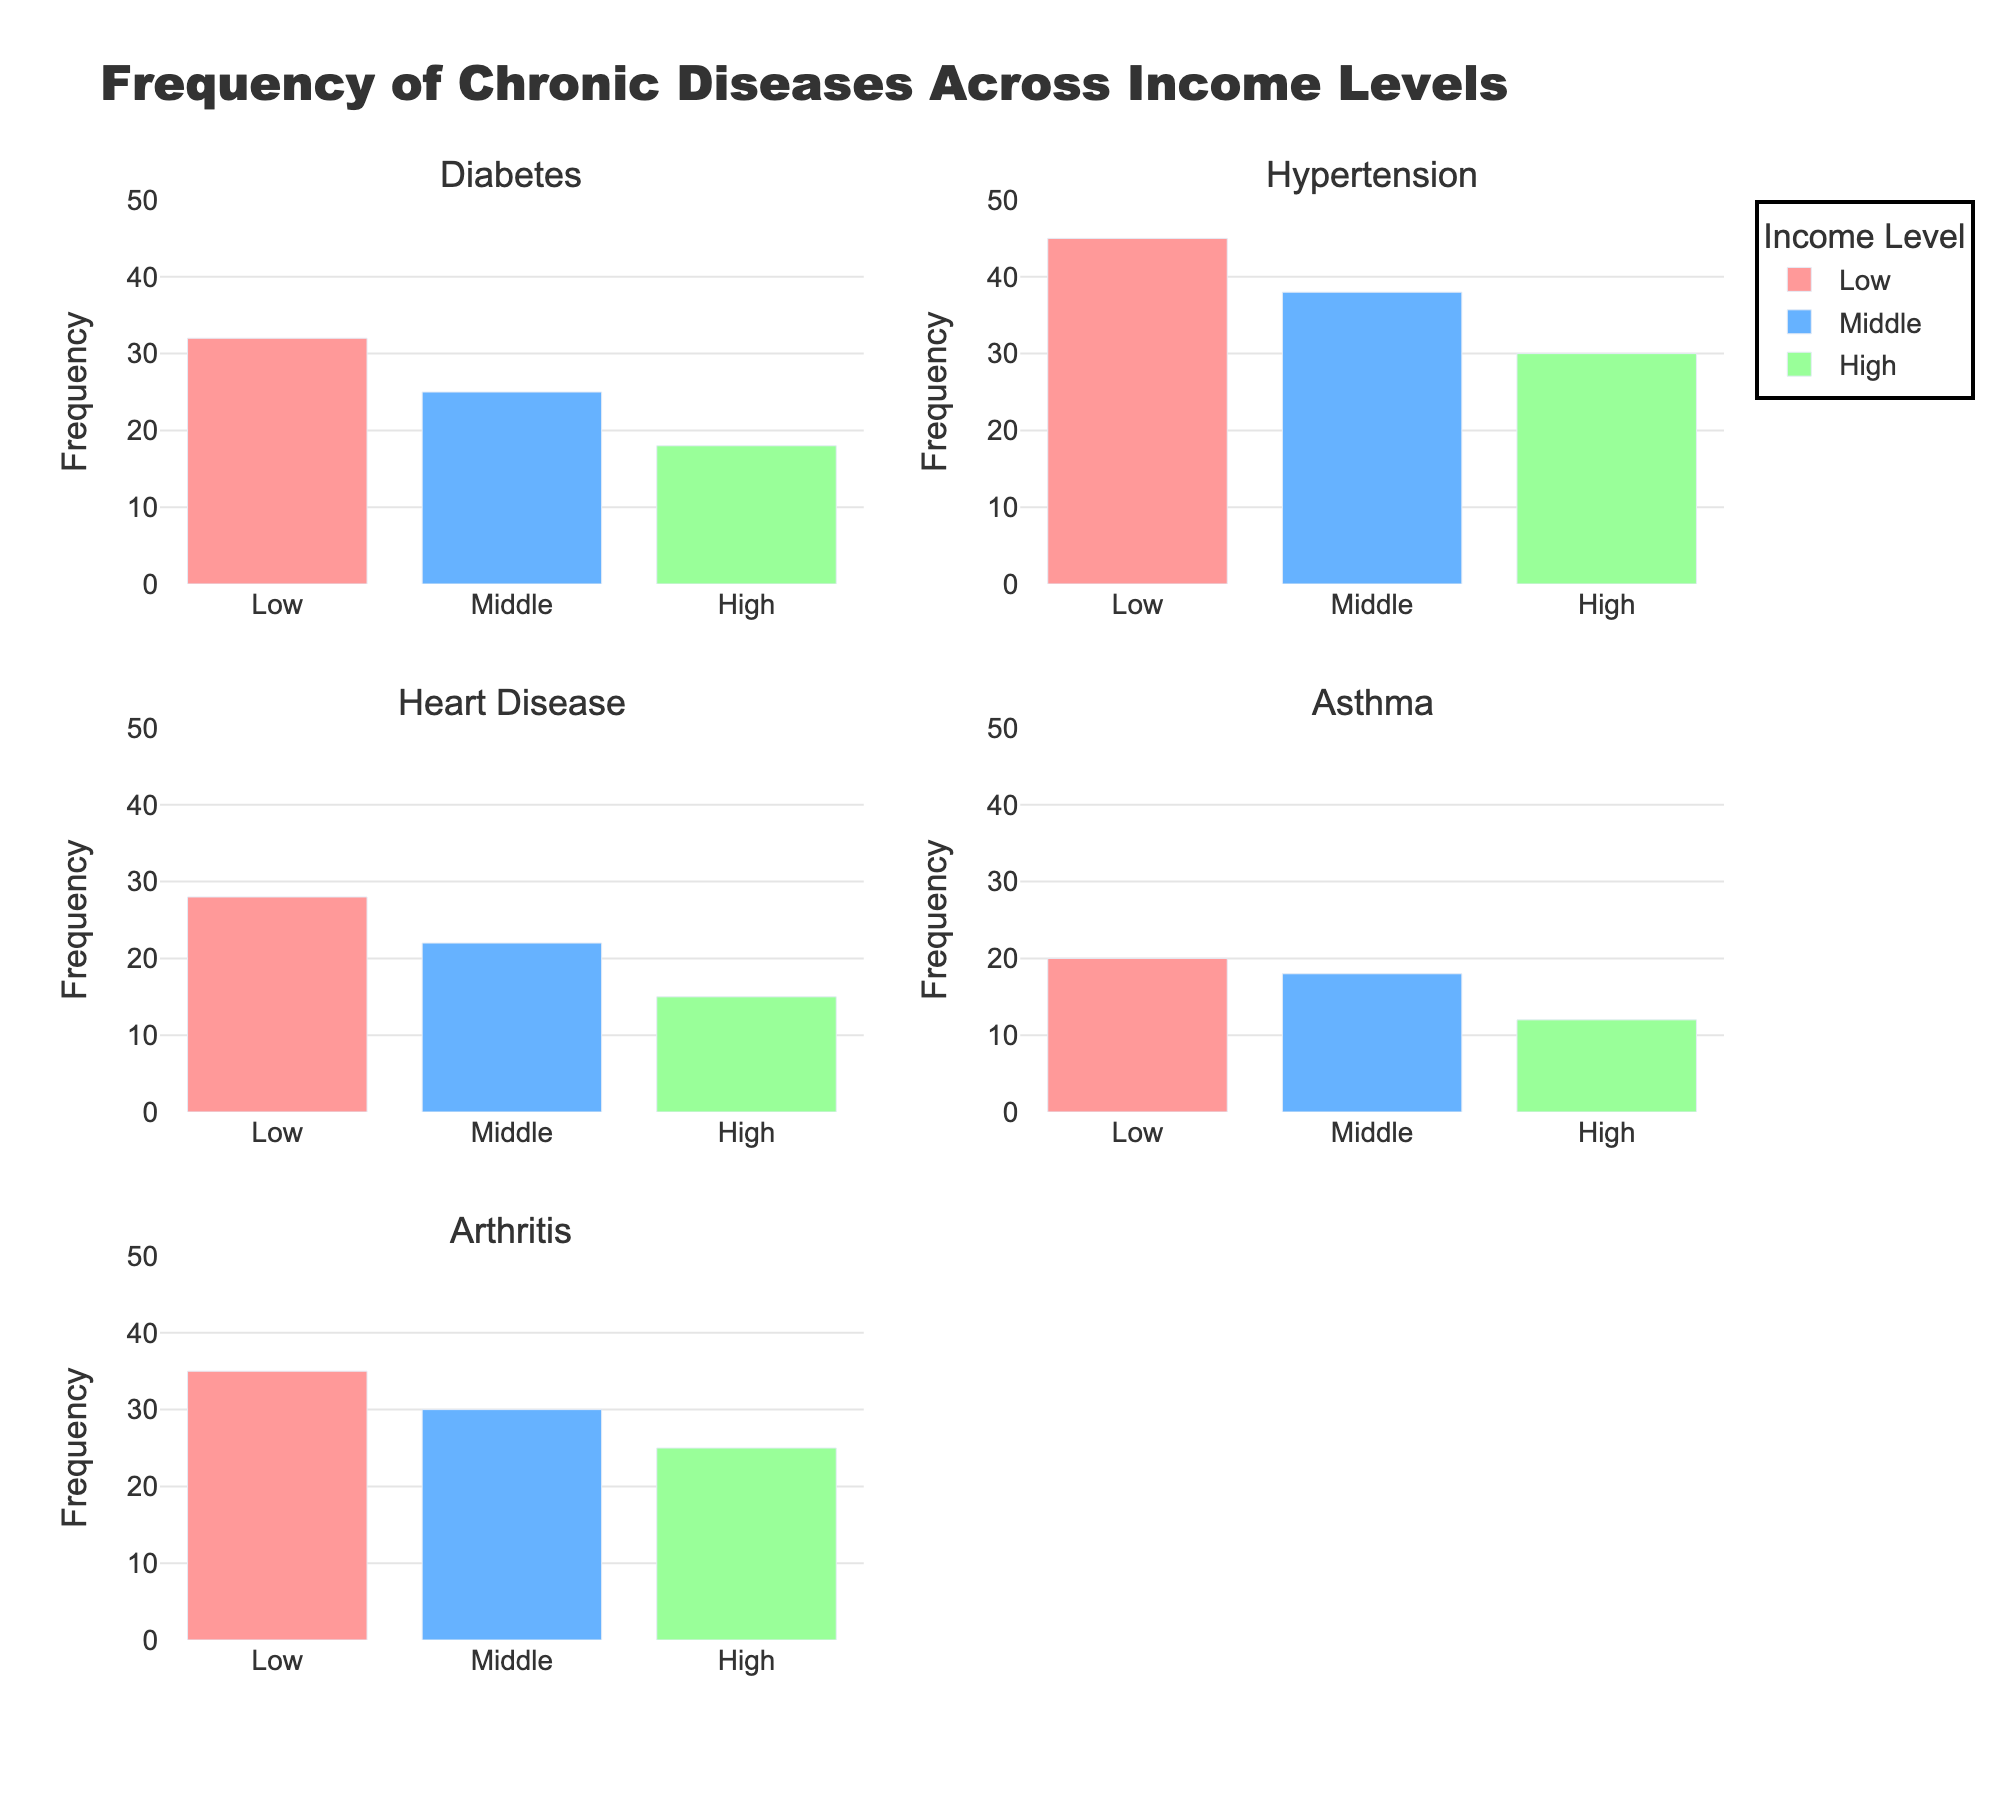What is the title of the figure? The title is usually located at the top of the chart and provides a summary of the information being displayed. In this case, it is "Frequency of Chronic Diseases Across Income Levels."
Answer: Frequency of Chronic Diseases Across Income Levels Which chronic disease has the lowest frequency in the high-income group? To answer this question, look at the bars representing the high-income group (colored green) across all the subplots and identify the one with the lowest height. Asthma has the lowest frequency with 12.
Answer: Asthma How many chronic diseases are displayed in the figure? Count the number of subplot titles, each representing a different chronic disease. There are five: Diabetes, Hypertension, Heart Disease, Asthma, and Arthritis.
Answer: 5 Comparing heart disease in low and high-income levels, which group has the higher frequency? Look at the bars for heart disease in both the low-income and high-income subplots. The low-income group has a frequency of 28, while the high-income group has a frequency of 15. Therefore, the low-income group has a higher frequency.
Answer: Low-income group What is the total frequency of asthma cases across all income levels? Add the frequency values for asthma across all income levels: Low (20), Middle (18), and High (12). The total is 20 + 18 + 12 = 50.
Answer: 50 Which income level has the highest frequency for diabetes? Compare the heights of the bars for diabetes across all income levels. The low-income group has the highest frequency with 32 cases.
Answer: Low-income group What is the average frequency of arthritis across all income levels? To find the average frequency of arthritis, sum the frequencies for all income levels: Low (35), Middle (30), and High (25). Then divide by 3 (number of income levels). The average is (35 + 30 + 25) / 3 = 30.
Answer: 30 For which chronic disease do the middle income and high-income groups have the same frequency? Review the frequencies for each chronic disease and find a match. Both middle and high-income groups have a frequency of 30 for hypertension.
Answer: Hypertension Which chronic disease shows the most significant frequency difference between the low and high-income levels? Calculate the absolute differences in frequencies between low and high-income levels for each disease: Diabetes (32–18=14), Hypertension (45–30=15), Heart Disease (28–15=13), Asthma (20–12=8), and Arthritis (35–25=10). The most significant difference is for Hypertension with a difference of 15.
Answer: Hypertension In the heart disease subplot, which income level has the closest frequency to 20? Check the heights of the bars for heart disease. The frequencies are Low (28), Middle (22), and High (15). The middle-income group with a frequency of 22 is closest to 20.
Answer: Middle-income group 